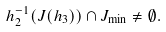Convert formula to latex. <formula><loc_0><loc_0><loc_500><loc_500>h _ { 2 } ^ { - 1 } ( J ( h _ { 3 } ) ) \cap J _ { \min } \neq \emptyset .</formula> 